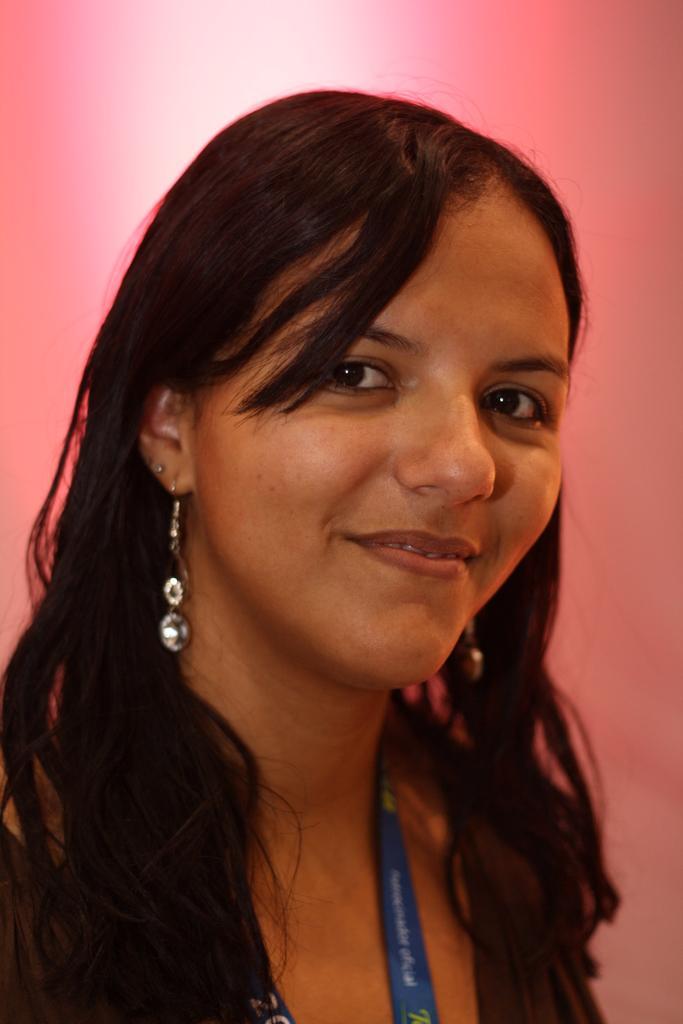Could you give a brief overview of what you see in this image? In the picture we can see woman's face who is smiling. 